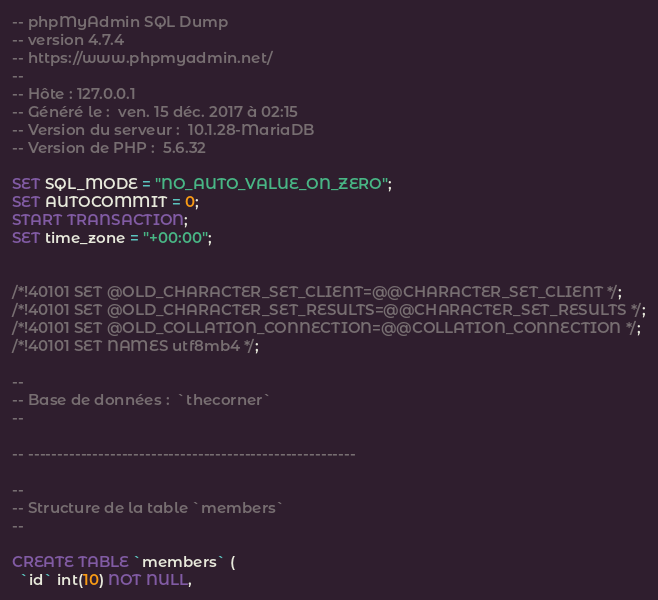Convert code to text. <code><loc_0><loc_0><loc_500><loc_500><_SQL_>-- phpMyAdmin SQL Dump
-- version 4.7.4
-- https://www.phpmyadmin.net/
--
-- Hôte : 127.0.0.1
-- Généré le :  ven. 15 déc. 2017 à 02:15
-- Version du serveur :  10.1.28-MariaDB
-- Version de PHP :  5.6.32

SET SQL_MODE = "NO_AUTO_VALUE_ON_ZERO";
SET AUTOCOMMIT = 0;
START TRANSACTION;
SET time_zone = "+00:00";


/*!40101 SET @OLD_CHARACTER_SET_CLIENT=@@CHARACTER_SET_CLIENT */;
/*!40101 SET @OLD_CHARACTER_SET_RESULTS=@@CHARACTER_SET_RESULTS */;
/*!40101 SET @OLD_COLLATION_CONNECTION=@@COLLATION_CONNECTION */;
/*!40101 SET NAMES utf8mb4 */;

--
-- Base de données :  `thecorner`
--

-- --------------------------------------------------------

--
-- Structure de la table `members`
--

CREATE TABLE `members` (
  `id` int(10) NOT NULL,</code> 